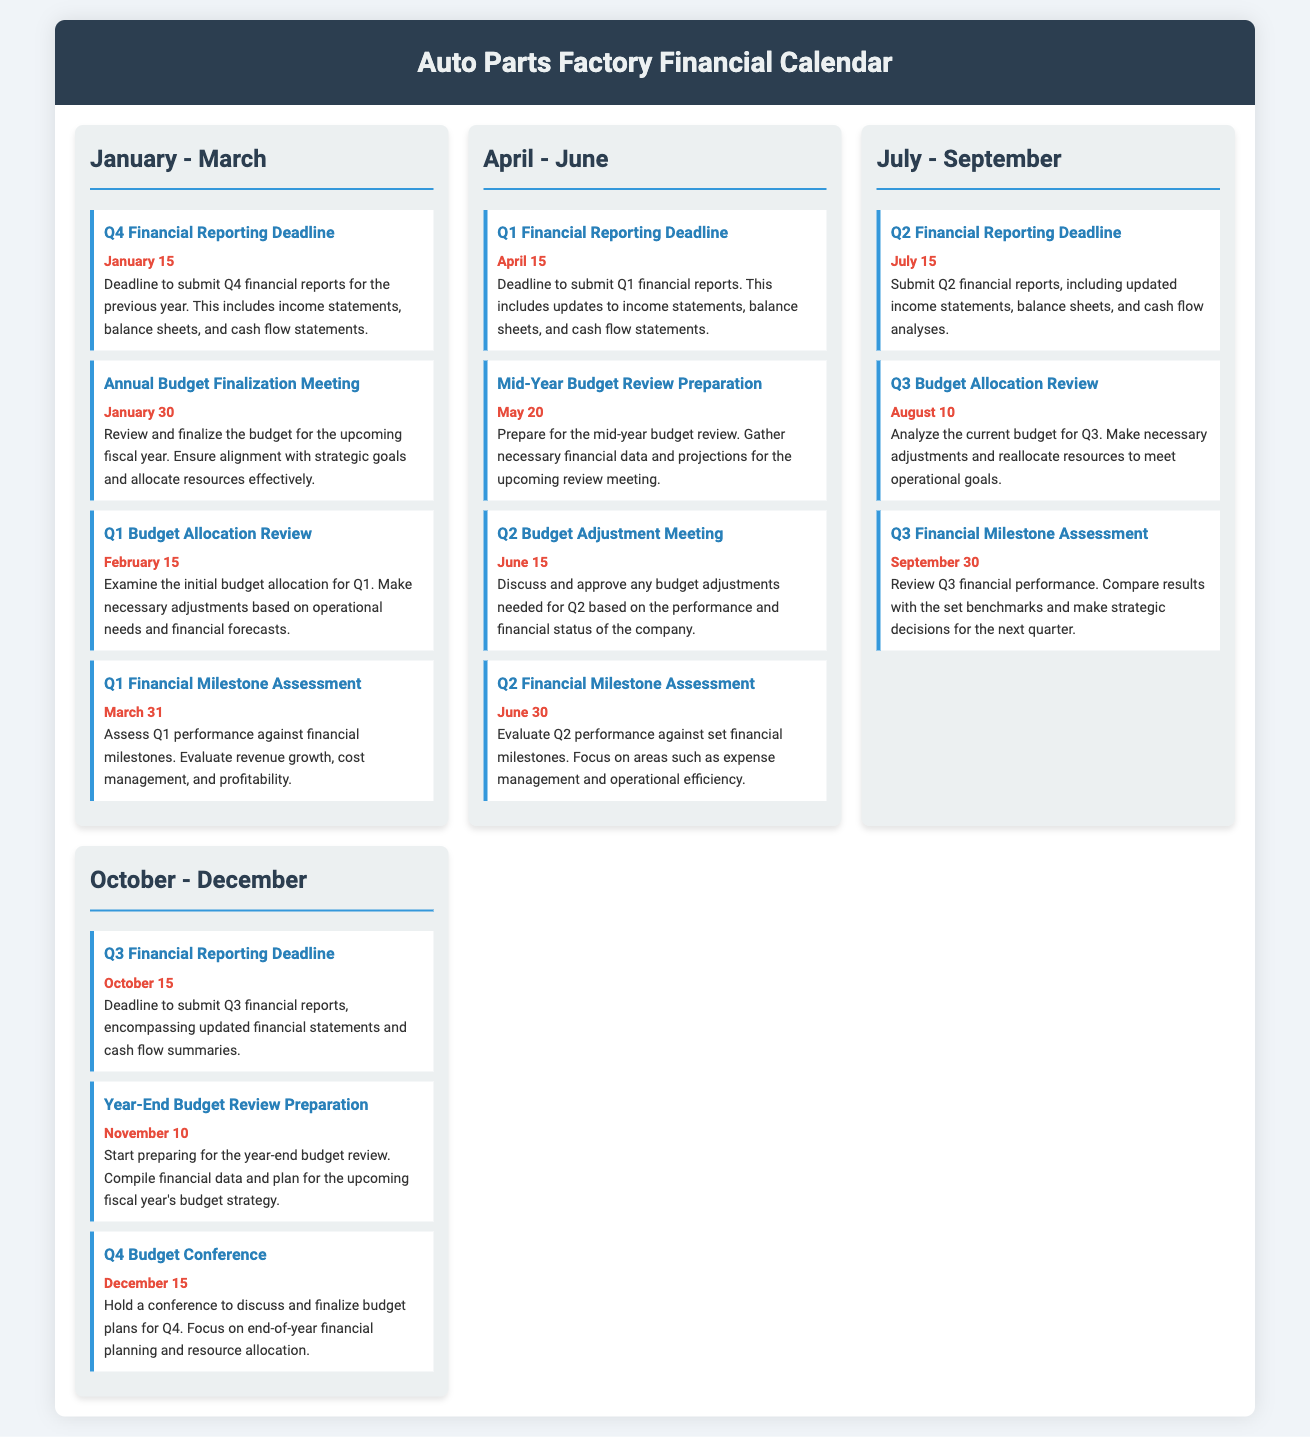What is the date for the Q1 Financial Reporting Deadline? The document states that the Q1 Financial Reporting Deadline is due on April 15.
Answer: April 15 When is the Annual Budget Finalization Meeting scheduled? According to the document, the Annual Budget Finalization Meeting is on January 30.
Answer: January 30 What is the purpose of the Q2 Budget Adjustment Meeting? The Q2 Budget Adjustment Meeting is held to discuss and approve budget adjustments needed based on performance.
Answer: Discuss and approve budget adjustments Which event occurs on December 15? The document lists the Q4 Budget Conference as occurring on December 15.
Answer: Q4 Budget Conference What financial reports are submitted by April 15? The document specifies that Q1 financial reports, which include updates to financial statements, are submitted by April 15.
Answer: Q1 financial reports How often are financial milestone assessments conducted? The document shows that financial milestone assessments occur quarterly.
Answer: Quarterly What happens on March 31 according to the calendar? March 31 is the date for the Q1 Financial Milestone Assessment according to the calendar.
Answer: Q1 Financial Milestone Assessment What is needed for the Mid-Year Budget Review Preparation on May 20? The document indicates that necessary financial data and projections are needed for the Mid-Year Budget Review Preparation.
Answer: Financial data and projections 